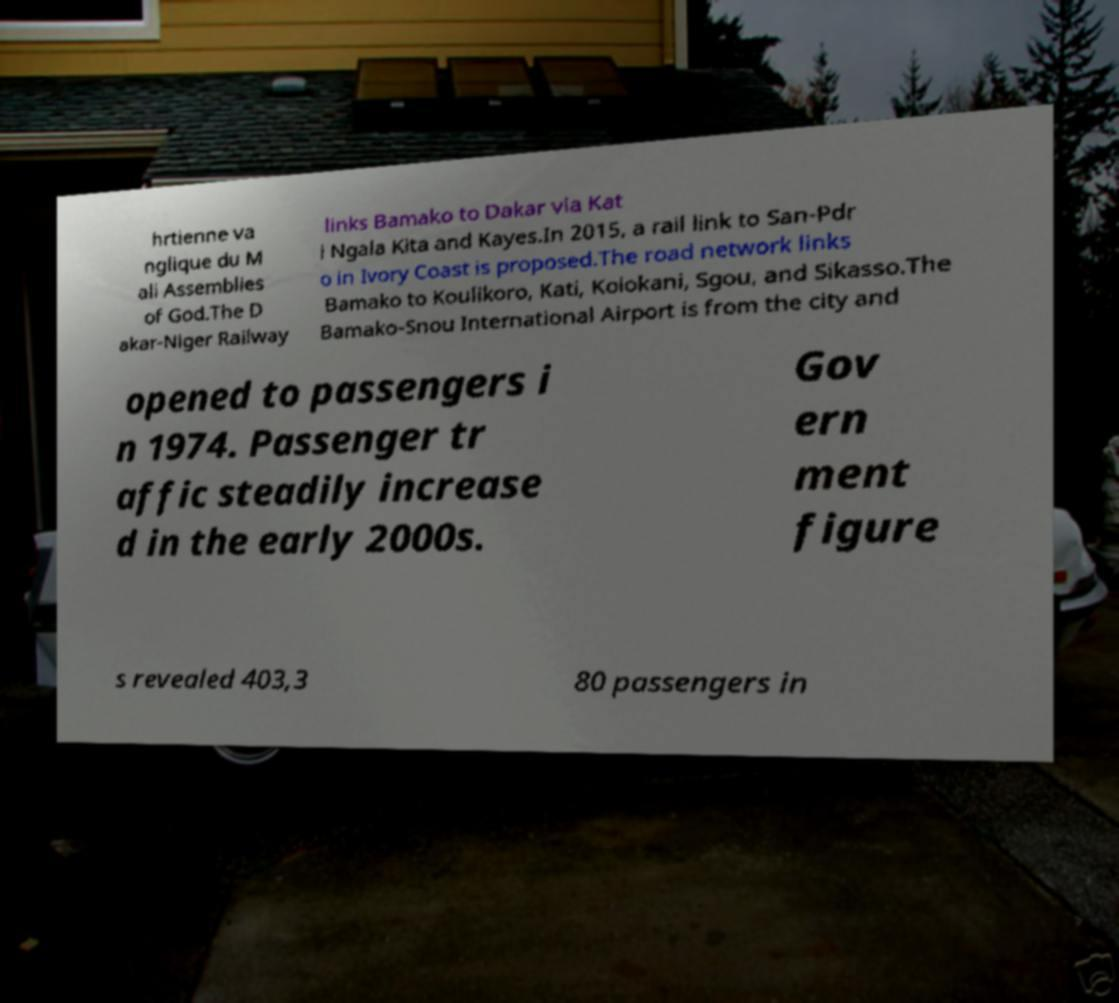I need the written content from this picture converted into text. Can you do that? hrtienne va nglique du M ali Assemblies of God.The D akar-Niger Railway links Bamako to Dakar via Kat i Ngala Kita and Kayes.In 2015, a rail link to San-Pdr o in Ivory Coast is proposed.The road network links Bamako to Koulikoro, Kati, Kolokani, Sgou, and Sikasso.The Bamako-Snou International Airport is from the city and opened to passengers i n 1974. Passenger tr affic steadily increase d in the early 2000s. Gov ern ment figure s revealed 403,3 80 passengers in 